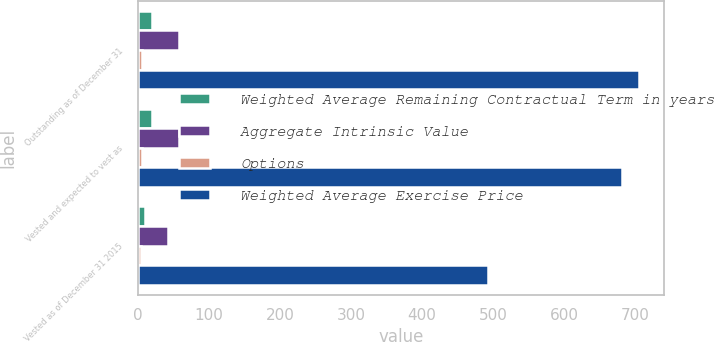Convert chart to OTSL. <chart><loc_0><loc_0><loc_500><loc_500><stacked_bar_chart><ecel><fcel>Outstanding as of December 31<fcel>Vested and expected to vest as<fcel>Vested as of December 31 2015<nl><fcel>Weighted Average Remaining Contractual Term in years<fcel>20.1<fcel>19<fcel>9.8<nl><fcel>Aggregate Intrinsic Value<fcel>57.84<fcel>56.98<fcel>42.78<nl><fcel>Options<fcel>6<fcel>6<fcel>4<nl><fcel>Weighted Average Exercise Price<fcel>705.8<fcel>681.4<fcel>492.6<nl></chart> 